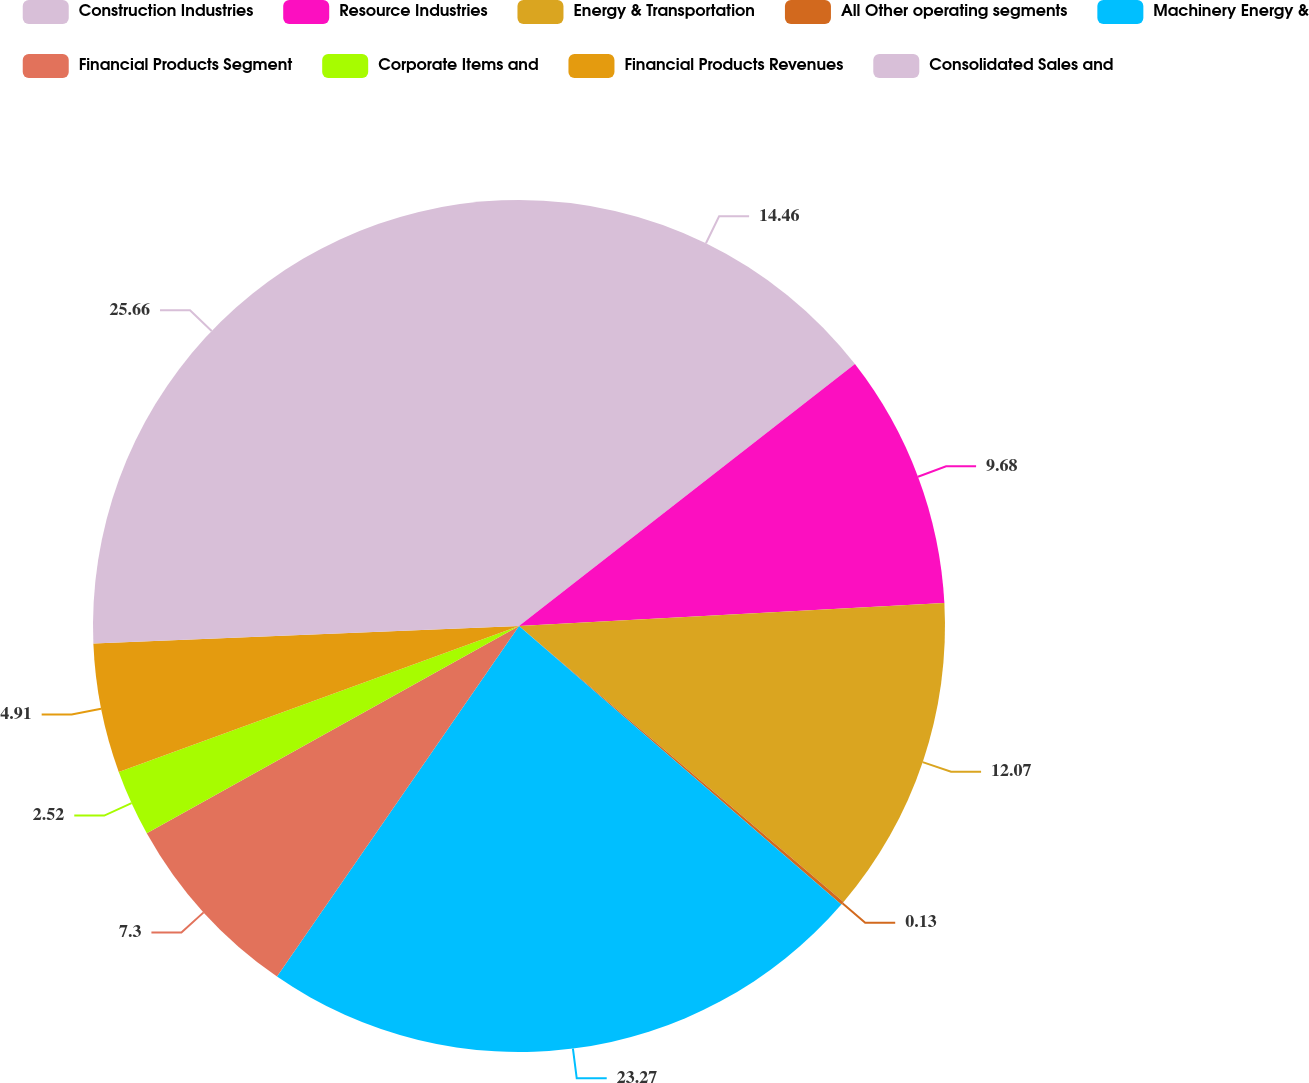Convert chart. <chart><loc_0><loc_0><loc_500><loc_500><pie_chart><fcel>Construction Industries<fcel>Resource Industries<fcel>Energy & Transportation<fcel>All Other operating segments<fcel>Machinery Energy &<fcel>Financial Products Segment<fcel>Corporate Items and<fcel>Financial Products Revenues<fcel>Consolidated Sales and<nl><fcel>14.46%<fcel>9.68%<fcel>12.07%<fcel>0.13%<fcel>23.27%<fcel>7.3%<fcel>2.52%<fcel>4.91%<fcel>25.65%<nl></chart> 